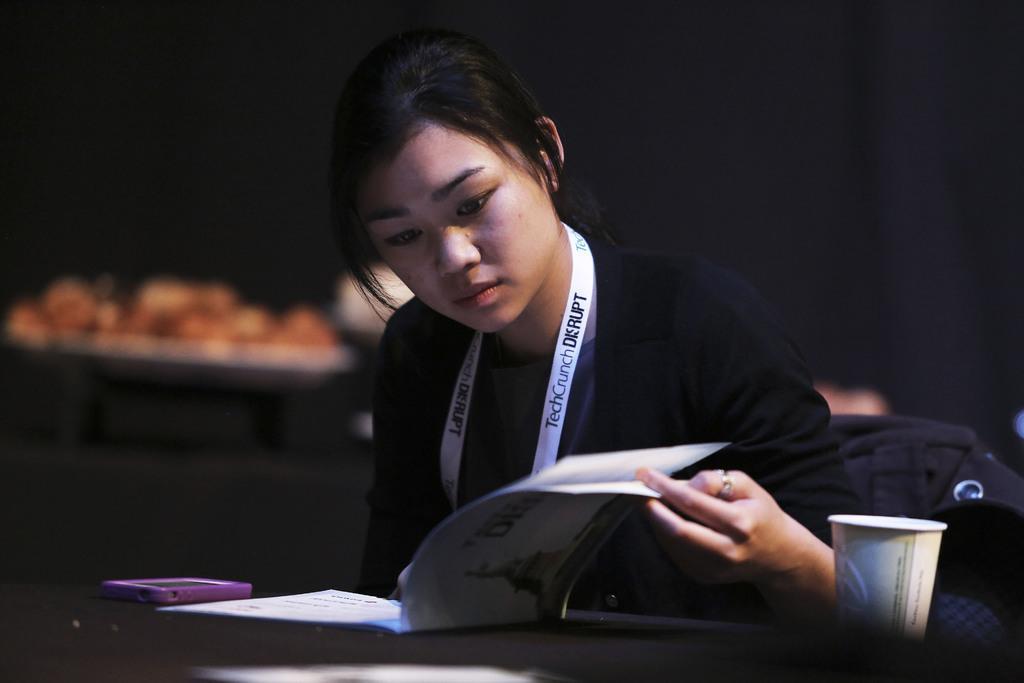In one or two sentences, can you explain what this image depicts? In this picture there is a girl in the center of the image, she is reading a book and there is a table in front of her on which, there is a cell phone and a glass. 